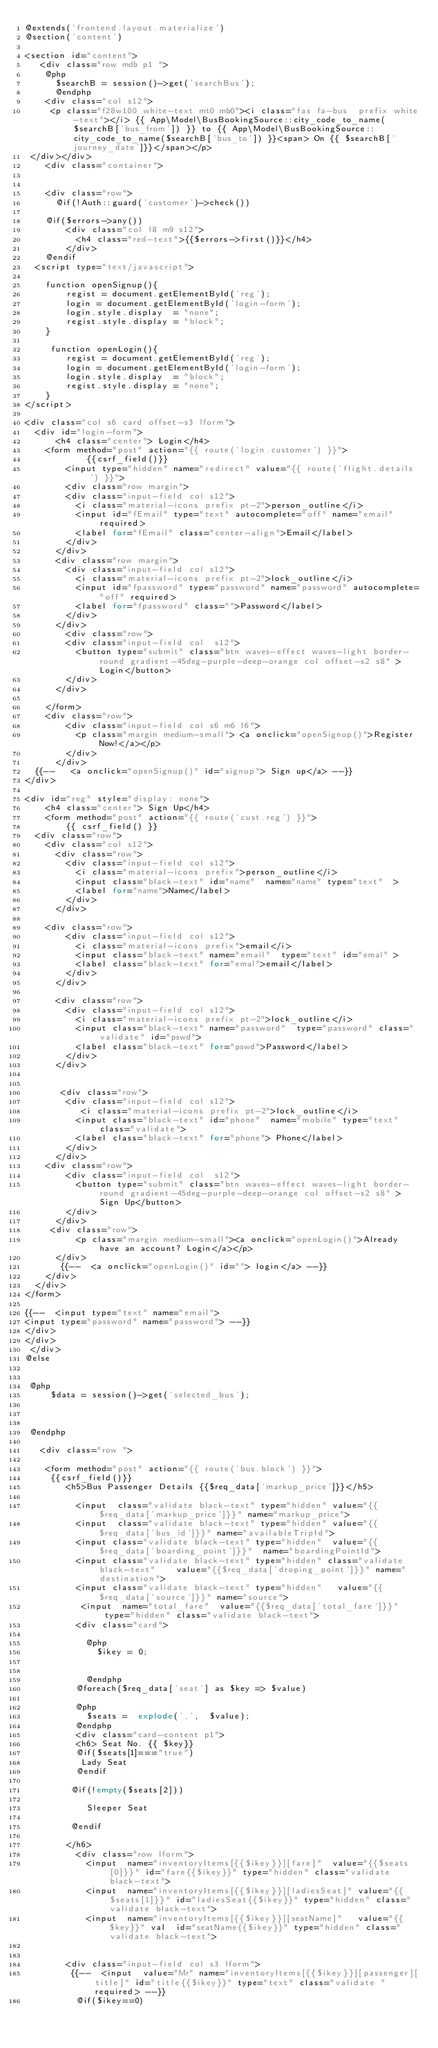<code> <loc_0><loc_0><loc_500><loc_500><_PHP_>@extends('frontend.layout.materialize')
@section('content')

<section id="content">
   <div class="row mdb p1 "> 
    @php
      $searchB = session()->get('searchBus');      
      @endphp
    <div class="col s12">
     <p class="f28w100 white-text mt0 mb0"><i class="fas fa-bus  prefix white-text"></i> {{ App\Model\BusBookingSource::city_code_to_name($searchB['bus_from']) }} to {{ App\Model\BusBookingSource::city_code_to_name($searchB['bus_to']) }}<span> On {{ $searchB['journey_date']}}</span></p>
 </div></div>
    <div class="container"> 

    
    <div class="row">
      @if(!Auth::guard('customer')->check())

    @if($errors->any())
        <div class="col l8 m9 s12"> 
          <h4 class="red-text">{{$errors->first()}}</h4>
        </div>
    @endif
  <script type="text/javascript">
    
    function openSignup(){
        regist = document.getElementById('reg');
        login = document.getElementById('login-form');
        login.style.display  = "none";
        regist.style.display = "block";
    }

     function openLogin(){
        regist = document.getElementById('reg');
        login = document.getElementById('login-form');
        login.style.display  = "block";
        regist.style.display = "none";
    }
</script>

<div class="col s6 card offset-s3 lform"> 
  <div id="login-form">
      <h4 class="center"> Login</h4>
    <form method="post" action="{{ route('login.customer') }}">
            {{csrf_field()}}
        <input type="hidden" name="redirect" value="{{ route('flight.details') }}">
        <div class="row margin">
        <div class="input-field col s12">
          <i class="material-icons prefix pt-2">person_outline</i>
          <input id="fEmail" type="text" autocomplete="off" name="email" required>
          <label for="fEmail" class="center-align">Email</label>
        </div>
      </div>
      <div class="row margin">
        <div class="input-field col s12">
          <i class="material-icons prefix pt-2">lock_outline</i>
          <input id="fpassword" type="password" name="password" autocomplete="off" required>
          <label for="fpassword" class="">Password</label>
        </div>
      </div>
        <div class="row">
        <div class="input-field col  s12">
          <button type="submit" class="btn waves-effect waves-light border-round gradient-45deg-purple-deep-orange col offset-s2 s8" >Login</button>
        </div>
      </div>
           
    </form>
    <div class="row">
        <div class="input-field col s6 m6 l6">
          <p class="margin medium-small"> <a onclick="openSignup()">Register Now!</a></p>
        </div>
      </div>
  {{--   <a onclick="openSignup()" id="signup"> Sign up</a> --}}
</div>

<div id="reg" style="display: none">
    <h4 class="center"> Sign Up</h4>
    <form method="post" action="{{ route('cust.reg') }}">
        {{ csrf_field() }}
  <div class="row">
    <div class="col s12">
      <div class="row">
        <div class="input-field col s12">
          <i class="material-icons prefix">person_outline</i>
          <input class="black-text" id="name"  name="name" type="text"  >
          <label for="name">Name</label>
        </div>
      </div>

    <div class="row">
        <div class="input-field col s12">
          <i class="material-icons prefix">email</i>
          <input class="black-text" name="email"  type="text" id="emal" >
          <label class="black-text" for="emal">email</label>
        </div>
      </div>

      <div class="row">
        <div class="input-field col s12">
          <i class="material-icons prefix pt-2">lock_outline</i>
          <input class="black-text" name="password"  type="password" class="validate" id="pswd">
          <label class="black-text" for="pswd">Password</label>
        </div>
      </div>


       <div class="row">
        <div class="input-field col s12">
           <i class="material-icons prefix pt-2">lock_outline</i>
          <input class="black-text" id="phone"  name="mobile" type="text" class="validate">
          <label class="black-text" for="phone"> Phone</label>
        </div>
      </div>
    <div class="row">
        <div class="input-field col  s12">
          <button type="submit" class="btn waves-effect waves-light border-round gradient-45deg-purple-deep-orange col offset-s2 s8" >Sign Up</button>
        </div>
      </div>
     <div class="row">
          <p class="margin medium-small"><a onclick="openLogin()">Already have an account? Login</a></p>        
      </div>
       {{--  <a onclick="openLogin()" id=""> login</a> --}}
    </div>
  </div>
</form>

{{--  <input type="text" name="email">
<input type="password" name="password"> --}}
</div>
</div>
 </div>  
@else


 @php
     $data = session()->get('selected_bus');

   

 @endphp

   <div class="row ">
   
    <form method="post" action="{{ route('bus.block') }}"> 
     {{csrf_field()}}
        <h5>Bus Passenger Details {{$req_data['markup_price']}}</h5>
        
          <input  class="validate black-text" type="hidden" value="{{$req_data['markup_price']}}" name="markup_price">
          <input  class="validate black-text" type="hidden" value="{{$req_data['bus_id']}}" name="availableTripId">
          <input class="validate black-text" type="hidden"  value="{{$req_data['boarding_point']}}"  name="boardingPointId">
          <input class="validate black-text" type="hidden" class="validate black-text"    value="{{$req_data['droping_point']}}" name="destination">
          <input class="validate black-text" type="hidden"   value="{{$req_data['source']}}" name="source">
           <input  name="total_fare"  value="{{$req_data['total_fare']}}"  type="hidden" class="validate black-text">
          <div class="card"> 

            @php
              $ikey = 0;

             
            @endphp
          @foreach($req_data['seat'] as $key => $value)

          @php
            $seats =  explode(',',  $value);
          @endphp
          <div class="card-content p1">
          <h6> Seat No. {{ $key}}   
          @if($seats[1]==="true")
           Lady Seat
          @endif

         @if(!empty($seats[2]))

            Sleeper Seat

         @endif

        </h6>
          <div class="row lform">
            <input  name="inventoryItems[{{$ikey}}][fare]"  value="{{$seats[0]}}" id="fare{{$ikey}}" type="hidden" class="validate black-text">
            <input  name="inventoryItems[{{$ikey}}][ladiesSeat]" value="{{$seats[1]}}" id="ladiesSeat{{$ikey}}" type="hidden" class="validate black-text">
            <input  name="inventoryItems[{{$ikey}}][seatName]"   value="{{$key}}" val  id="seatName{{$ikey}}" type="hidden" class="validate black-text">

        
        <div class="input-field col s3 lform">
         {{--  <input  value="Mr" name="inventoryItems[{{$ikey}}][passenger][title]" id="title{{$ikey}}" type="text" class="validate " required> --}}
          @if($ikey==0)</code> 